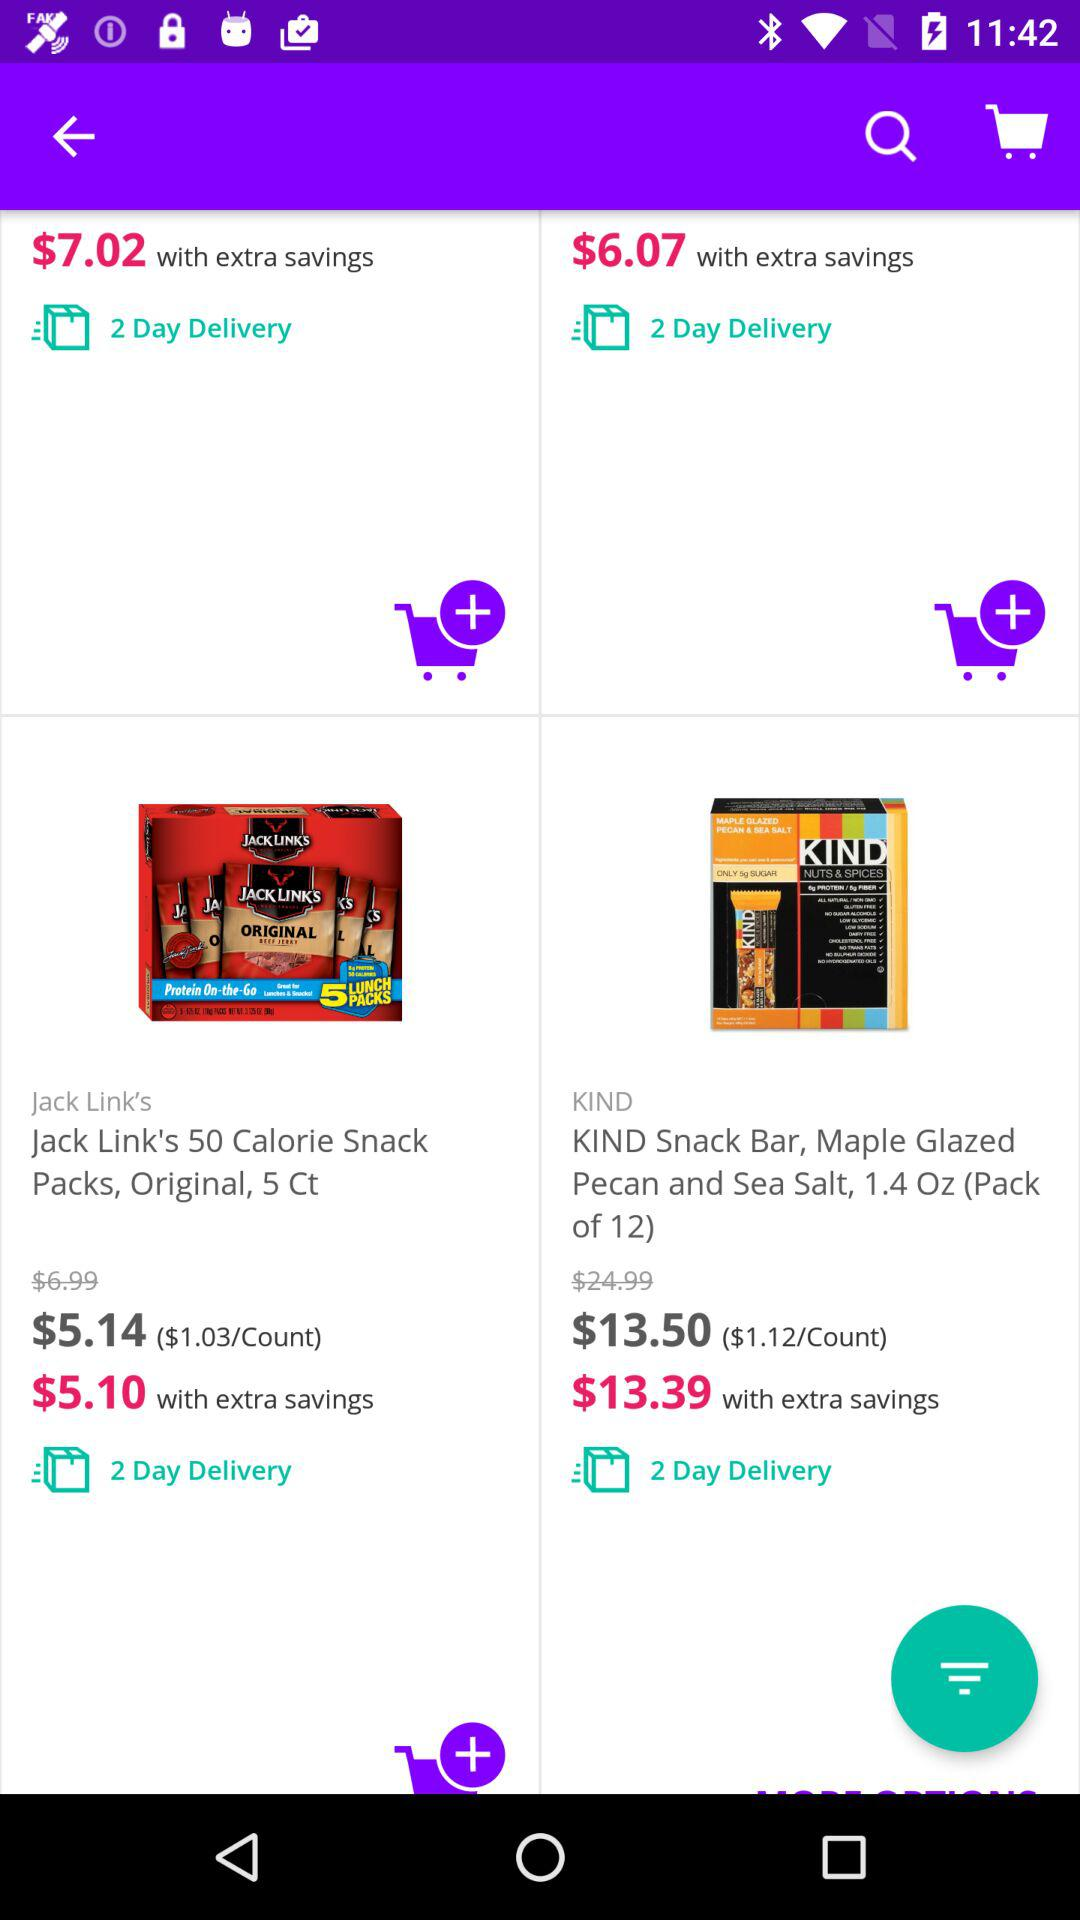What is the price of "Jack Link's 50 Calorie Snack" before extra savings? The price before extra savings is $5.14. 